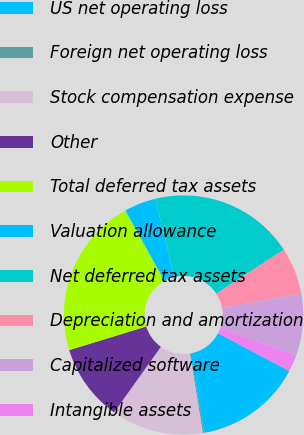Convert chart to OTSL. <chart><loc_0><loc_0><loc_500><loc_500><pie_chart><fcel>US net operating loss<fcel>Foreign net operating loss<fcel>Stock compensation expense<fcel>Other<fcel>Total deferred tax assets<fcel>Valuation allowance<fcel>Net deferred tax assets<fcel>Depreciation and amortization<fcel>Capitalized software<fcel>Intangible assets<nl><fcel>14.47%<fcel>0.21%<fcel>12.43%<fcel>10.4%<fcel>21.65%<fcel>4.29%<fcel>19.61%<fcel>6.32%<fcel>8.36%<fcel>2.25%<nl></chart> 